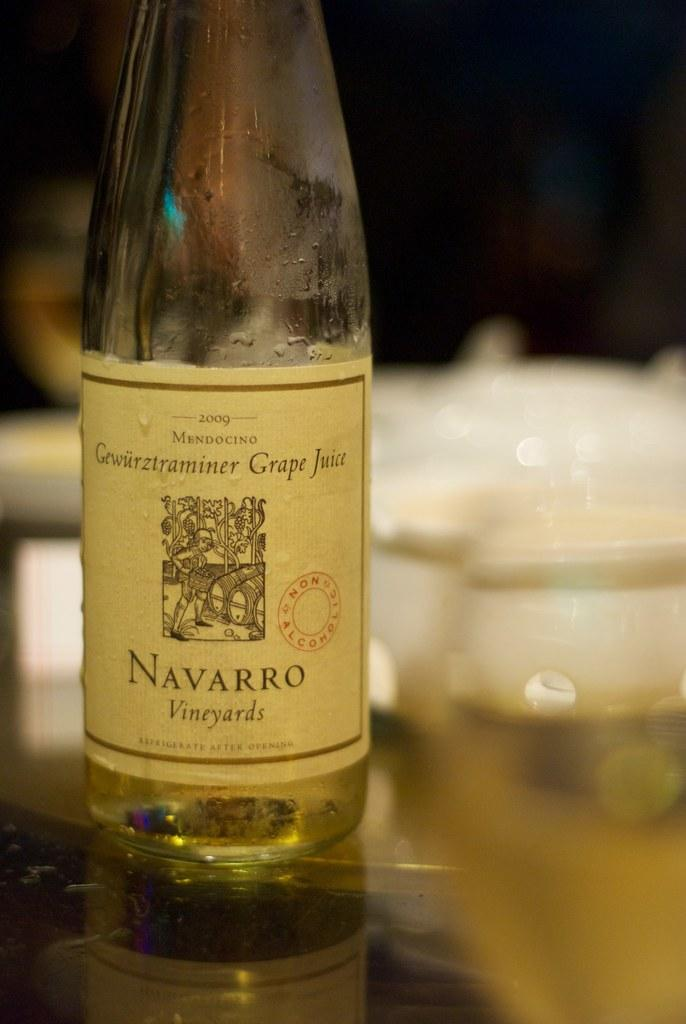<image>
Give a short and clear explanation of the subsequent image. bottle of 2009 navarro vineyards grape juice on a reflective surface 